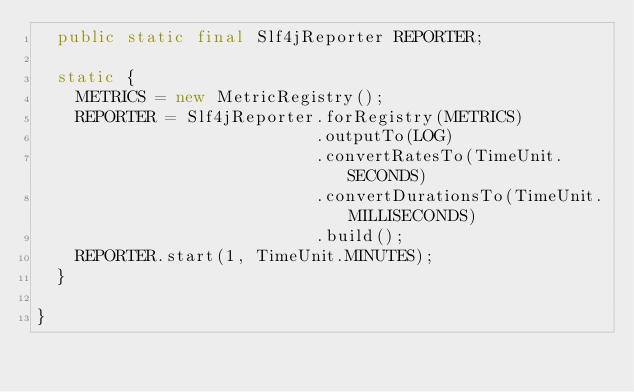Convert code to text. <code><loc_0><loc_0><loc_500><loc_500><_Java_>  public static final Slf4jReporter REPORTER;

  static {
    METRICS = new MetricRegistry();
    REPORTER = Slf4jReporter.forRegistry(METRICS)
                            .outputTo(LOG)
                            .convertRatesTo(TimeUnit.SECONDS)
                            .convertDurationsTo(TimeUnit.MILLISECONDS)
                            .build();
    REPORTER.start(1, TimeUnit.MINUTES);
  }

}
</code> 